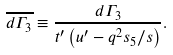Convert formula to latex. <formula><loc_0><loc_0><loc_500><loc_500>\overline { d \Gamma _ { 3 } } \equiv \frac { d \Gamma _ { 3 } } { t ^ { \prime } \left ( u ^ { \prime } - q ^ { 2 } s _ { 5 } / s \right ) } .</formula> 